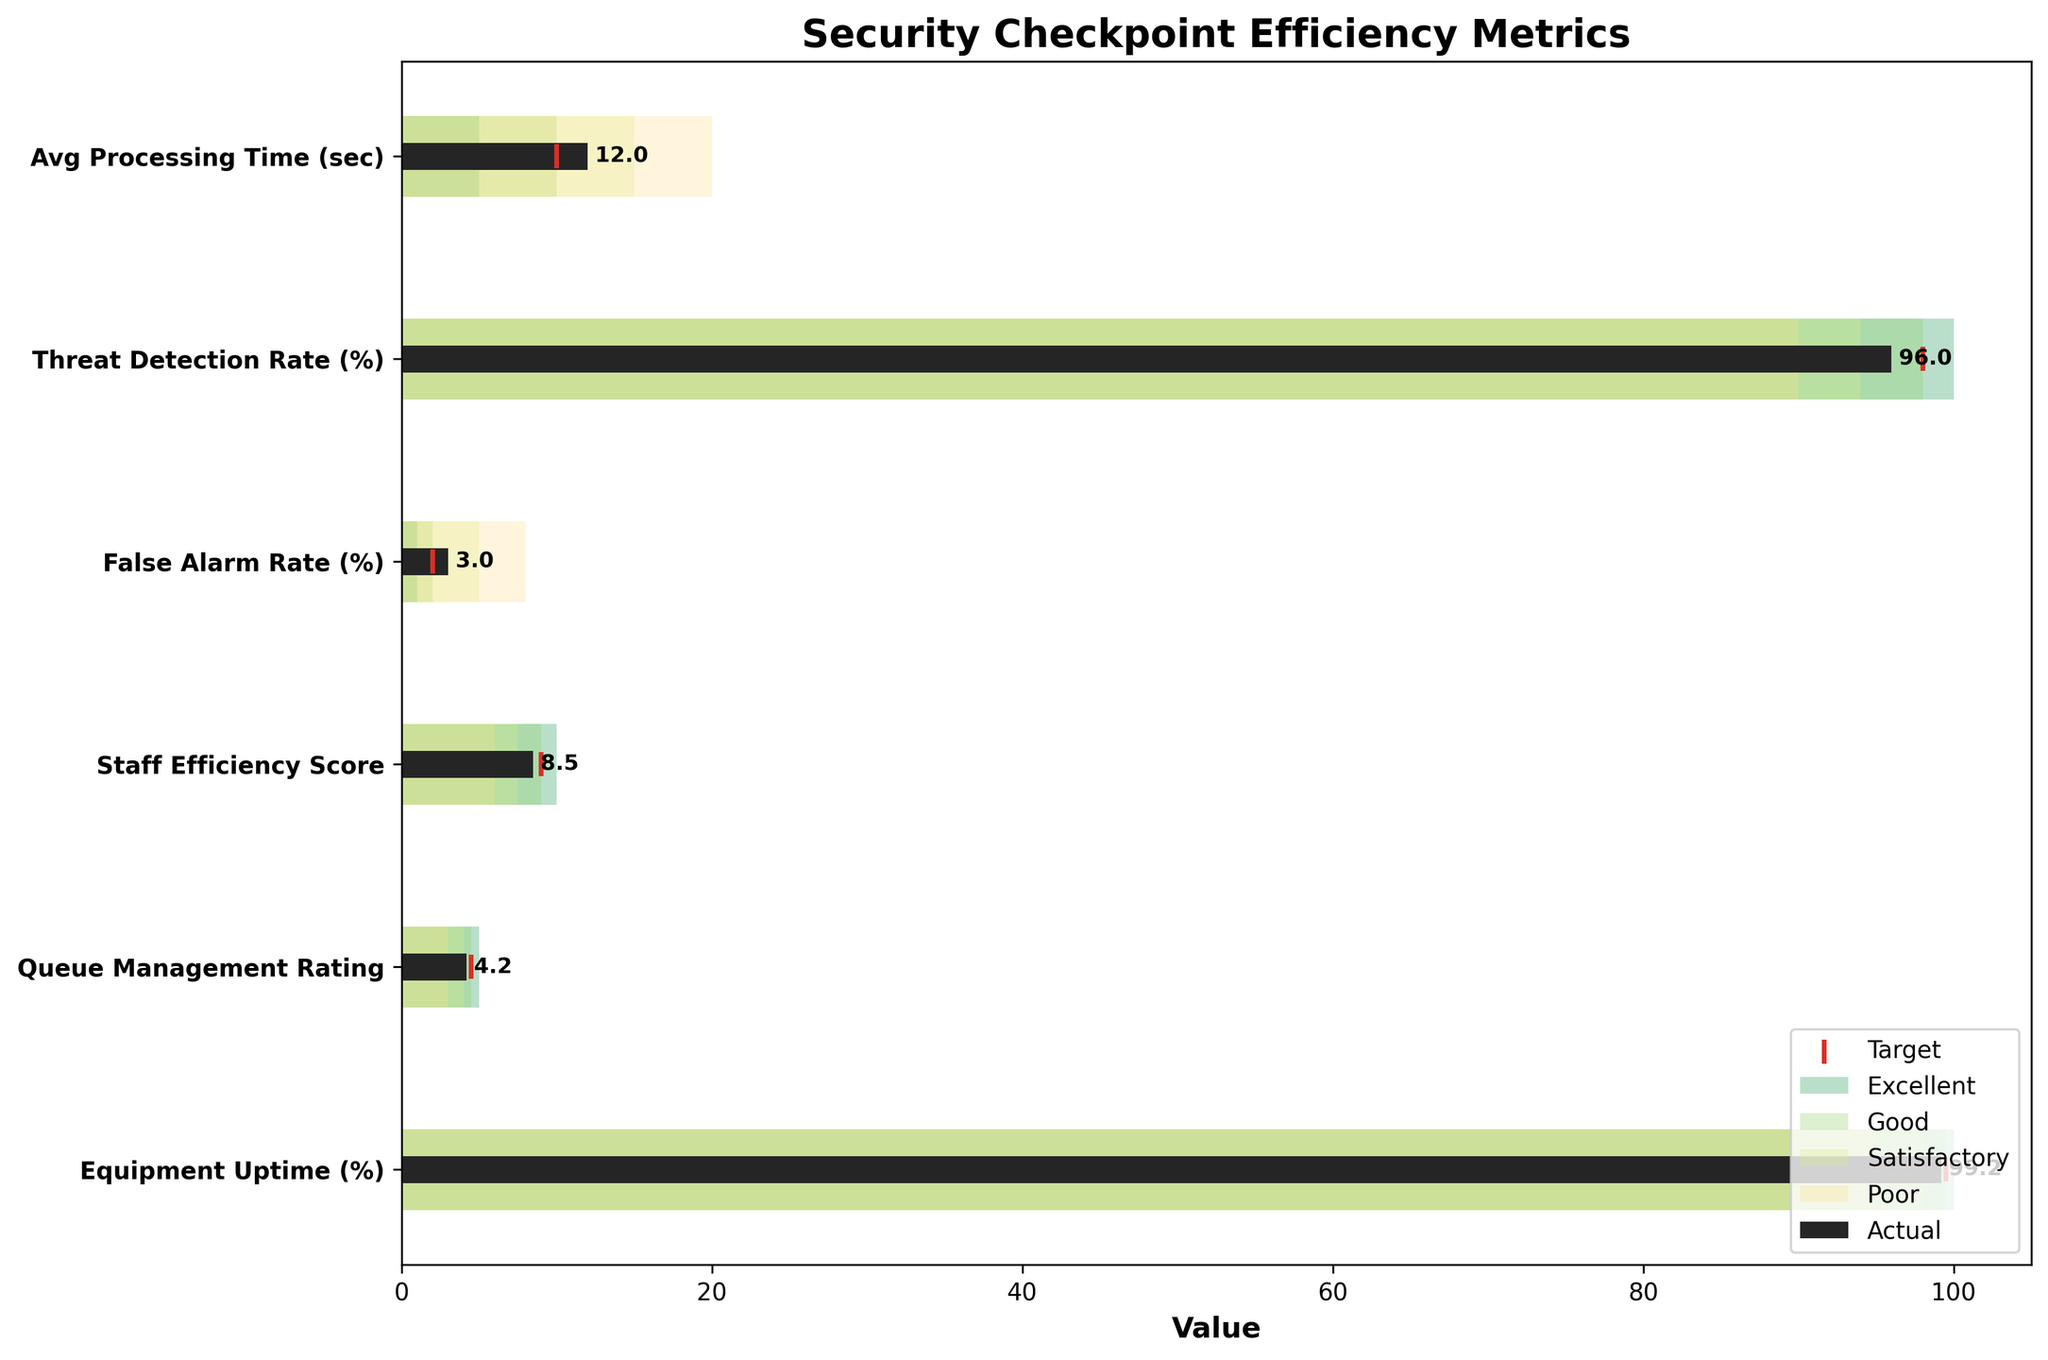What's the title of the chart? The title of the chart is displayed at the top and serves to inform the viewer of the overall subject of the graphic.
Answer: Security Checkpoint Efficiency Metrics How many metrics are shown in the chart? The metrics are listed on the y-axis of the chart. Count the number of labels to determine the total number.
Answer: 6 What is the Actual value for the Avg Processing Time (sec)? Locate the specific bar for "Avg Processing Time (sec)" and check the label on the bar to find the Actual value.
Answer: 12 Which metric has the highest Actual value? Compare the heights of the Actual value bars for each metric to identify the one that is tallest.
Answer: Avg Processing Time (sec) Is the Threat Detection Rate (%)'s Actual value above or below its Target? Check the position of the Actual value bar for "Threat Detection Rate (%)" and see if it is higher or lower than the Target marker.
Answer: Below What's the difference between the Actual and Target values for the False Alarm Rate (%)? Subtract the Target value of 2% from the Actual value of 3%.
Answer: 1% Which metric has the closest Actual value to its Target? Compare the difference between Actual and Target values for all metrics to find the smallest difference.
Answer: Queue Management Rating Is the Staff Efficiency Score in the 'Satisfactory' range? Identify the qualitative range boundaries: determine if the Actual value for "Staff Efficiency Score" falls within the 'Satisfactory' range (7.5 - 9).
Answer: Yes What color represents the 'Excellent' qualitative range? Look at the legend on the chart to identify the color used for the 'Excellent' range.
Answer: Green How many metrics have their Actual values in the 'Poor' range? Check each metric to see if their Actual values fall within the defined boundaries for the 'Poor' range and count them.
Answer: 1 